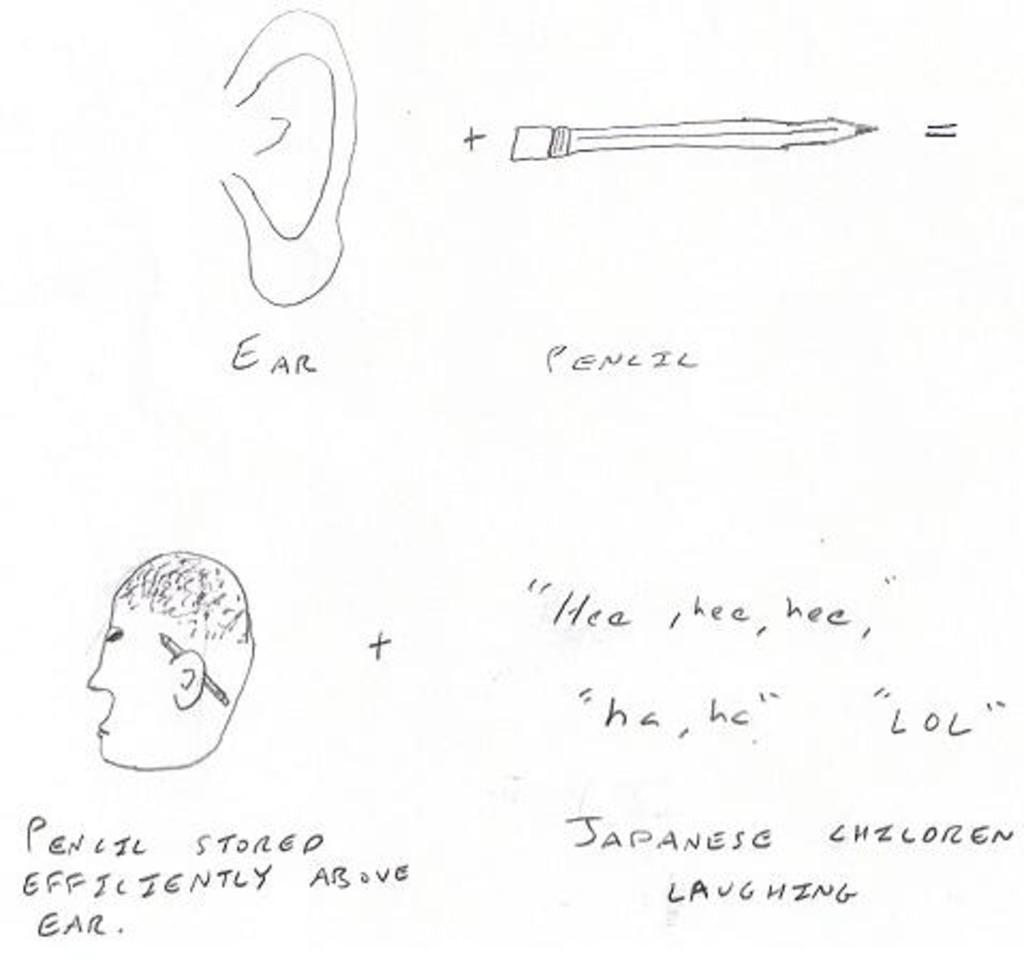<image>
Create a compact narrative representing the image presented. Ear, Pencil, and a drawing of an ear and head on a piece of white paper. 